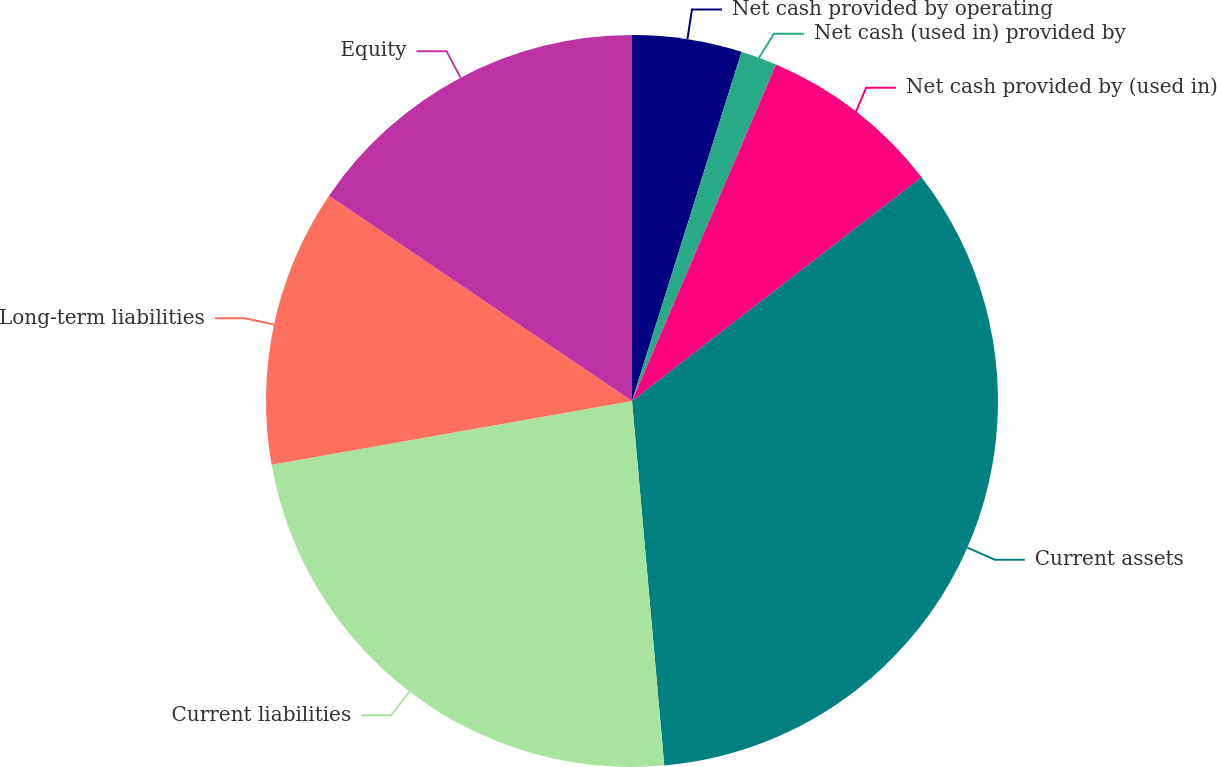Convert chart. <chart><loc_0><loc_0><loc_500><loc_500><pie_chart><fcel>Net cash provided by operating<fcel>Net cash (used in) provided by<fcel>Net cash provided by (used in)<fcel>Current assets<fcel>Current liabilities<fcel>Long-term liabilities<fcel>Equity<nl><fcel>4.84%<fcel>1.6%<fcel>8.09%<fcel>34.07%<fcel>23.62%<fcel>12.27%<fcel>15.52%<nl></chart> 